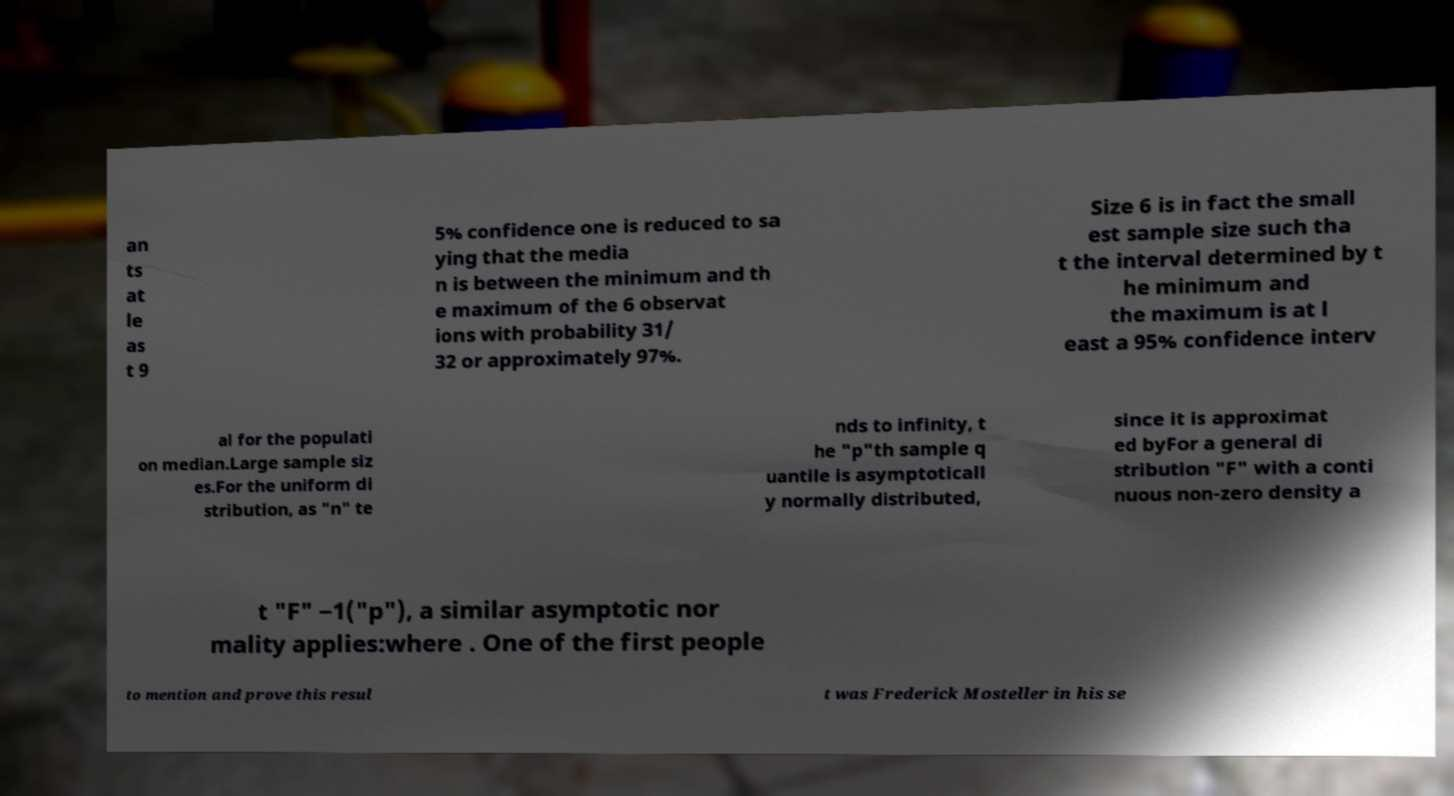Can you accurately transcribe the text from the provided image for me? an ts at le as t 9 5% confidence one is reduced to sa ying that the media n is between the minimum and th e maximum of the 6 observat ions with probability 31/ 32 or approximately 97%. Size 6 is in fact the small est sample size such tha t the interval determined by t he minimum and the maximum is at l east a 95% confidence interv al for the populati on median.Large sample siz es.For the uniform di stribution, as "n" te nds to infinity, t he "p"th sample q uantile is asymptoticall y normally distributed, since it is approximat ed byFor a general di stribution "F" with a conti nuous non-zero density a t "F" −1("p"), a similar asymptotic nor mality applies:where . One of the first people to mention and prove this resul t was Frederick Mosteller in his se 